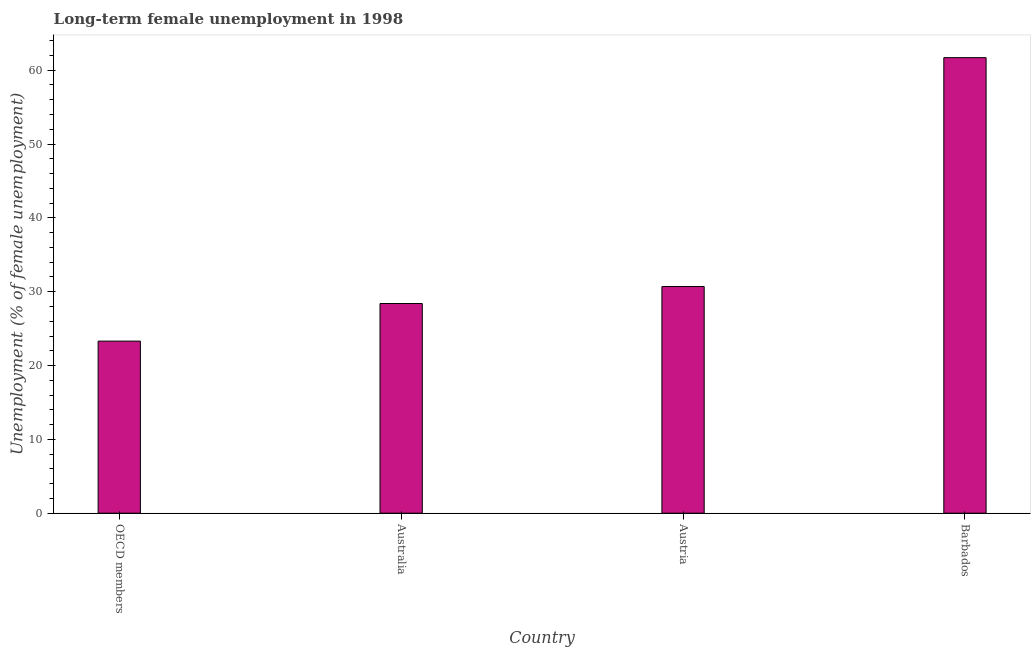Does the graph contain grids?
Provide a short and direct response. No. What is the title of the graph?
Provide a succinct answer. Long-term female unemployment in 1998. What is the label or title of the X-axis?
Give a very brief answer. Country. What is the label or title of the Y-axis?
Keep it short and to the point. Unemployment (% of female unemployment). What is the long-term female unemployment in OECD members?
Provide a short and direct response. 23.31. Across all countries, what is the maximum long-term female unemployment?
Your response must be concise. 61.7. Across all countries, what is the minimum long-term female unemployment?
Offer a terse response. 23.31. In which country was the long-term female unemployment maximum?
Your answer should be very brief. Barbados. In which country was the long-term female unemployment minimum?
Provide a short and direct response. OECD members. What is the sum of the long-term female unemployment?
Provide a short and direct response. 144.11. What is the difference between the long-term female unemployment in Austria and Barbados?
Keep it short and to the point. -31. What is the average long-term female unemployment per country?
Your answer should be compact. 36.03. What is the median long-term female unemployment?
Ensure brevity in your answer.  29.55. What is the ratio of the long-term female unemployment in Barbados to that in OECD members?
Give a very brief answer. 2.65. What is the difference between the highest and the second highest long-term female unemployment?
Your answer should be compact. 31. Is the sum of the long-term female unemployment in Australia and Austria greater than the maximum long-term female unemployment across all countries?
Provide a short and direct response. No. What is the difference between the highest and the lowest long-term female unemployment?
Offer a very short reply. 38.39. In how many countries, is the long-term female unemployment greater than the average long-term female unemployment taken over all countries?
Ensure brevity in your answer.  1. Are all the bars in the graph horizontal?
Provide a short and direct response. No. What is the difference between two consecutive major ticks on the Y-axis?
Your answer should be very brief. 10. What is the Unemployment (% of female unemployment) in OECD members?
Your response must be concise. 23.31. What is the Unemployment (% of female unemployment) in Australia?
Keep it short and to the point. 28.4. What is the Unemployment (% of female unemployment) of Austria?
Your answer should be compact. 30.7. What is the Unemployment (% of female unemployment) of Barbados?
Provide a succinct answer. 61.7. What is the difference between the Unemployment (% of female unemployment) in OECD members and Australia?
Keep it short and to the point. -5.09. What is the difference between the Unemployment (% of female unemployment) in OECD members and Austria?
Provide a short and direct response. -7.39. What is the difference between the Unemployment (% of female unemployment) in OECD members and Barbados?
Offer a very short reply. -38.39. What is the difference between the Unemployment (% of female unemployment) in Australia and Austria?
Provide a succinct answer. -2.3. What is the difference between the Unemployment (% of female unemployment) in Australia and Barbados?
Keep it short and to the point. -33.3. What is the difference between the Unemployment (% of female unemployment) in Austria and Barbados?
Provide a succinct answer. -31. What is the ratio of the Unemployment (% of female unemployment) in OECD members to that in Australia?
Your answer should be compact. 0.82. What is the ratio of the Unemployment (% of female unemployment) in OECD members to that in Austria?
Offer a terse response. 0.76. What is the ratio of the Unemployment (% of female unemployment) in OECD members to that in Barbados?
Ensure brevity in your answer.  0.38. What is the ratio of the Unemployment (% of female unemployment) in Australia to that in Austria?
Your answer should be very brief. 0.93. What is the ratio of the Unemployment (% of female unemployment) in Australia to that in Barbados?
Offer a very short reply. 0.46. What is the ratio of the Unemployment (% of female unemployment) in Austria to that in Barbados?
Offer a terse response. 0.5. 